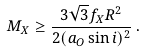<formula> <loc_0><loc_0><loc_500><loc_500>M _ { X } \geq \frac { 3 \sqrt { 3 } f _ { X } R ^ { 2 } } { 2 ( a _ { O } \sin i ) ^ { 2 } } \, .</formula> 